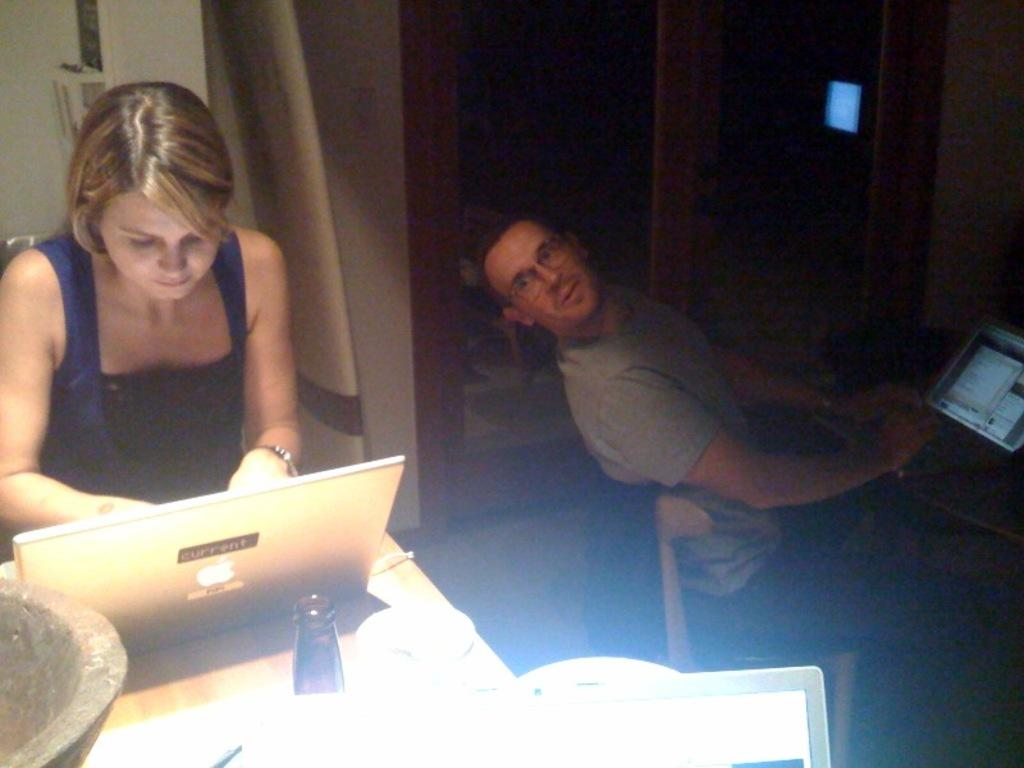How many people are present in the image? There are two people in the image, a woman and a man. What are the woman and man doing in the image? Both the woman and man are sitting on chairs. What is on the table in the image? There is a bottle and a laptop on the table. What can be seen in the background of the image? There is a wall in the background of the image. How many lines can be seen connecting the ducks in the image? There are no ducks present in the image, so there are no lines connecting them. What type of arm is visible on the woman in the image? There is no specific arm mentioned or visible in the image; the woman is simply sitting on a chair. 